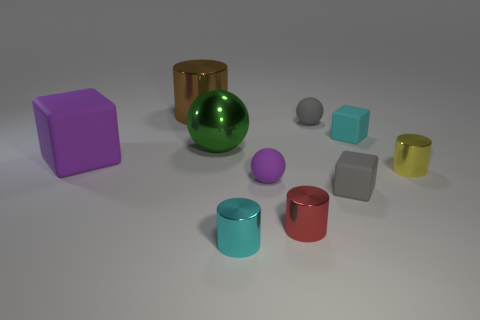What can you infer about the lighting and mood of this scene? The lighting in the scene is soft and evenly dispersed, creating gentle and diffused shadows beneath each object. There is no harsh or directional light visible, suggesting an overcast sky or studio lighting with diffusers. The mood evoked by the image is quite neutral and calm with a clean, minimalistic feel, often associated with a controlled environment like a photography studio or a 3D rendering. The lack of vibrant colors or dynamic composition adds to the serene and undisturbed atmosphere. 